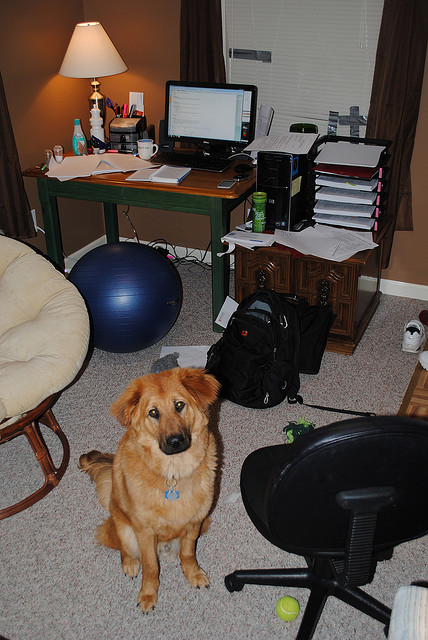<image>What is the name of this dog? I don't know the name of this dog. It could be 'brownie', 'fido', 'sheppard', 'rufus', or 'rover'. What is the name of this dog? I don't know the name of this dog. It could be Brownie, Fido, Sheppard, Rufus, or Rover. 